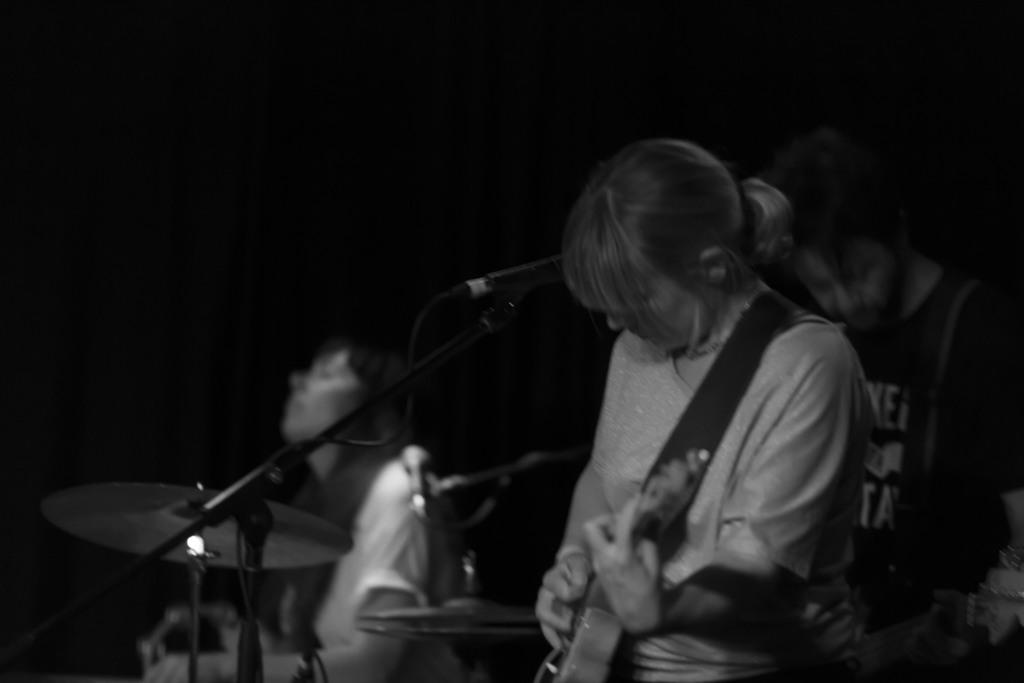How many people are playing musical instruments in the image? There are three persons playing musical instruments in the image. What is the object beside one of the persons? There is a mic beside one of the persons. What is the color of the background in the image? The background of the image is dark. What type of vase can be seen in the image? There is no vase present in the image. What show are the persons performing in the image? The image does not provide information about a show or performance. 